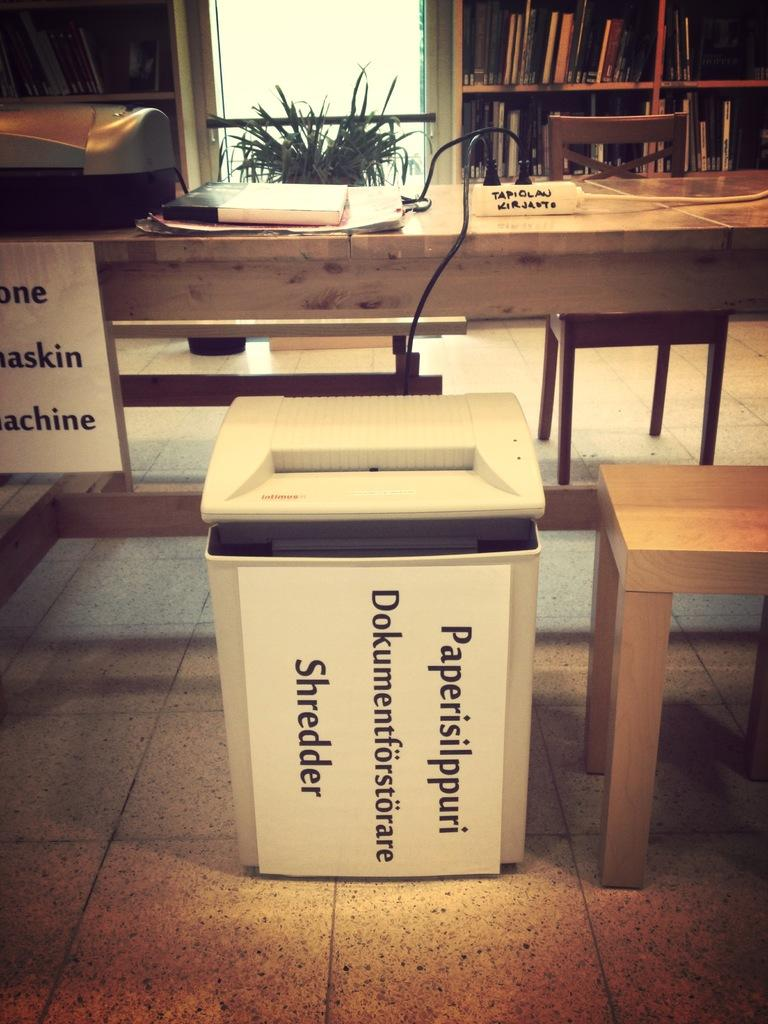What type of furniture is present in the image? There are wooden stools and a wooden table in the image. What is on top of the table? There are objects on the table. What can be seen in the background of the image? There is a plant pot and books on shelves in the background of the image, as well as other objects. What type of zinc is being used to write on the wooden stools in the image? There is no zinc or writing activity present in the image. 